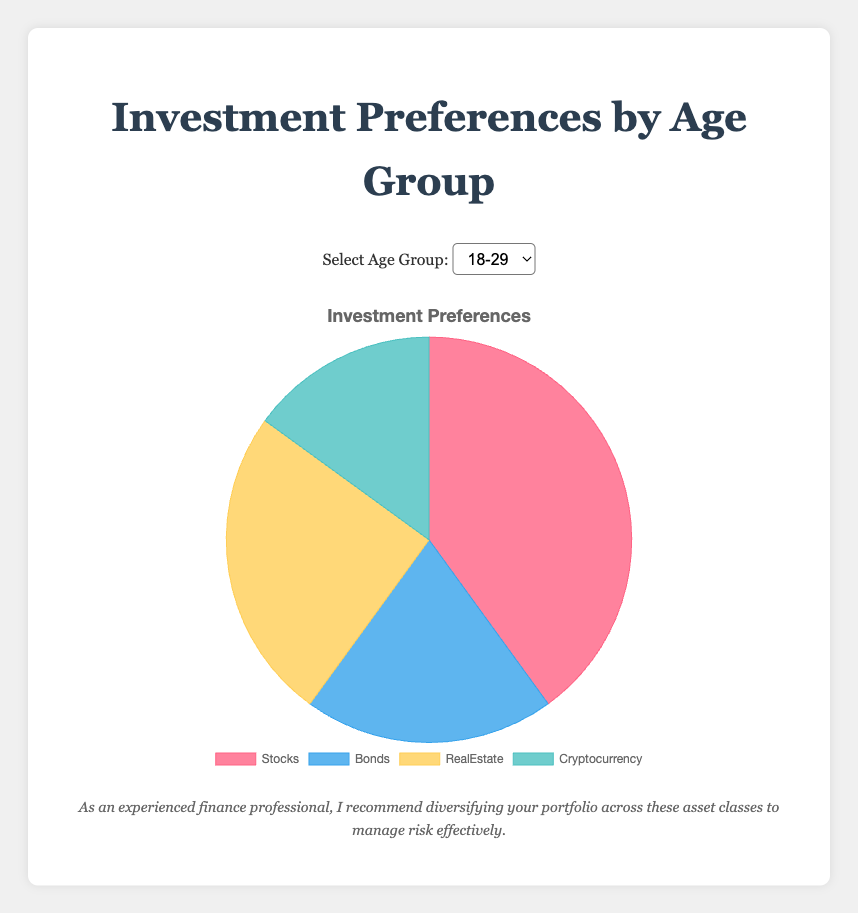Which Age Group invests the most in Bonds? The Age Group with the highest percentage for Bonds is the 65+ group, with 50%.
Answer: 65+ Which Age Group has the least preference for Cryptocurrency? The Age Group with the smallest percentage invested in Cryptocurrency is both the 30-49, 50-64, and 65+ groups, each with 10%.
Answer: 30-49, 50-64, and 65+ How many Age Groups allocate more than 30% to Real Estate? The Age Groups that allocate more than 30% to Real Estate are 18-29 with 25% and 30-49 with 30%. Only one Age Group allocates more than 30%, which is the 30-49 group.
Answer: 1 What is the total percentage allocation for Stocks and Cryptocurrency for the 18-29 Age Group? The percentage allocated to Stocks is 40% and to Cryptocurrency is 15%. Sum these two percentages: 40% + 15% = 55%.
Answer: 55% Which investment type has the highest allocation overall in the 50-64 Age Group? The investment type with the highest allocation in the 50-64 Age Group is Bonds with 40%.
Answer: Bonds How does the preference for Bonds change from the 18-29 Age Group to the 65+ Age Group? For the 18-29 Age Group, the Bonds allocation is 20% while for the 65+ Age Group, it is 50%. The increase from 20% to 50% is a 30 percentage point increase.
Answer: 30 percentage points Compare the allocation to Stocks between the 18-29 and 50-64 Age Groups. The 18-29 Age Group allocates 40% to Stocks, while the 50-64 Age Group allocates 30%. The 18-29 group invests 10 percentage points more in Stocks compared to the 50-64 group.
Answer: 10 percentage points more Which Age Group has the highest preference for Real Estate? The Age Group 30-49 allocates the highest to Real Estate with 30%.
Answer: 30-49 Among which Age Groups is the allocation to Cryptocurrency exactly the same? The allocation to Cryptocurrency is the same for the 30-49, 50-64, and 65+ Age Groups, each with 10%.
Answer: 30-49, 50-64, and 65+ What is the sum of the allocations for non-Stocks investments in the 65+ Age Group? The percentages for Bonds, Real Estate, and Cryptocurrency in the 65+ Age Group are 50%, 15%, and 10% respectively. Adding these gives 50% + 15% + 10% = 75%.
Answer: 75% 